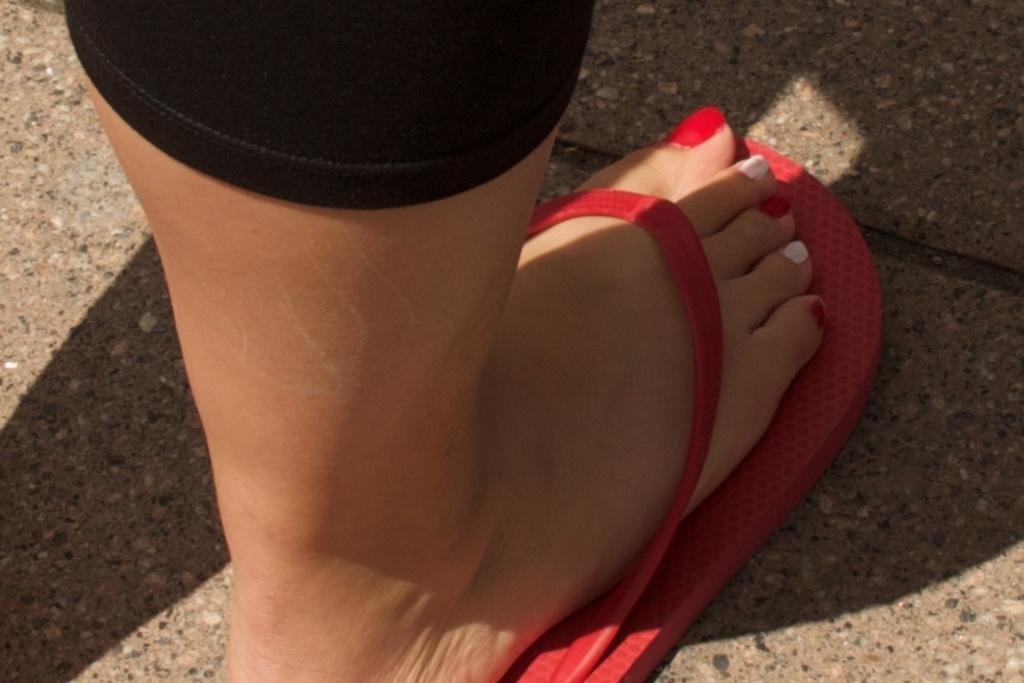Please provide a concise description of this image. In the image we can see there is a leg of a person wearing red colour rubber slippers. There is nail polish on the toe fingers which are in red and white colour. 